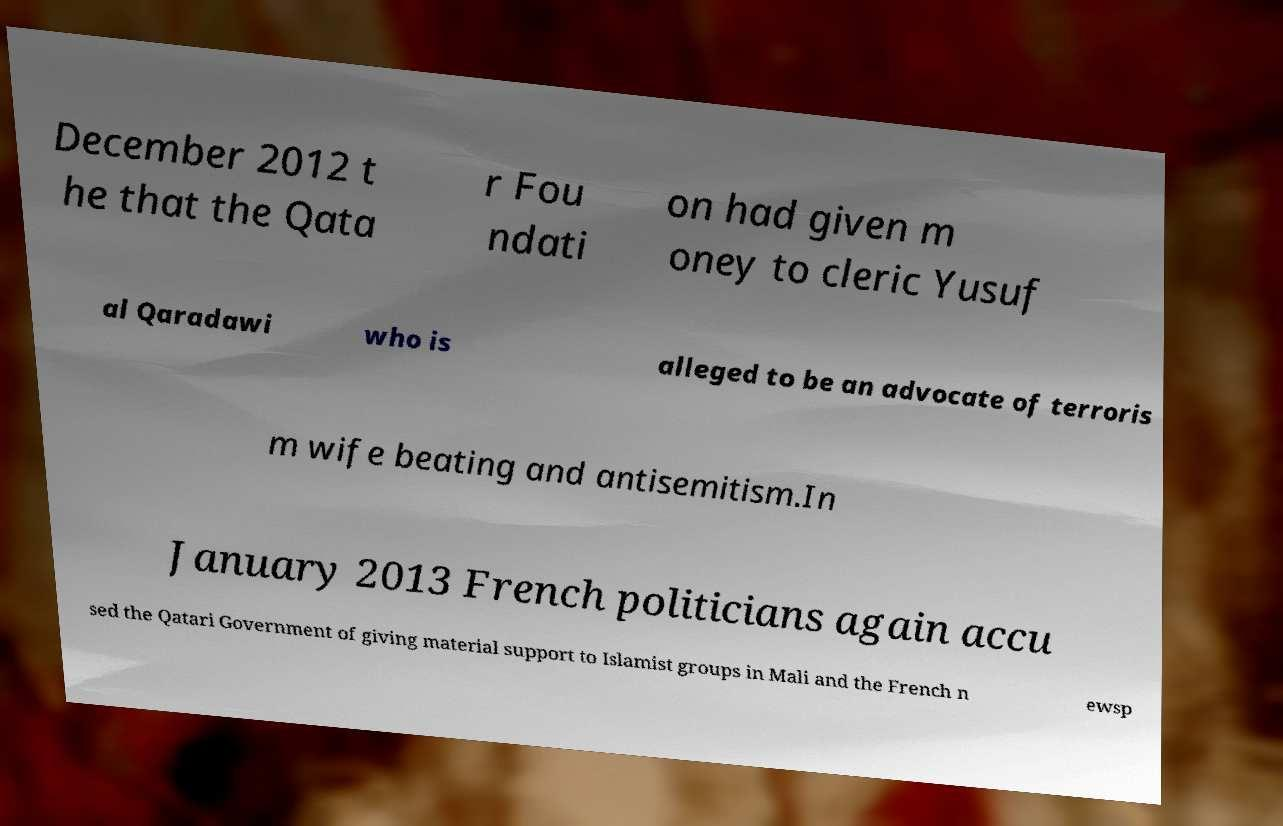Please read and relay the text visible in this image. What does it say? December 2012 t he that the Qata r Fou ndati on had given m oney to cleric Yusuf al Qaradawi who is alleged to be an advocate of terroris m wife beating and antisemitism.In January 2013 French politicians again accu sed the Qatari Government of giving material support to Islamist groups in Mali and the French n ewsp 